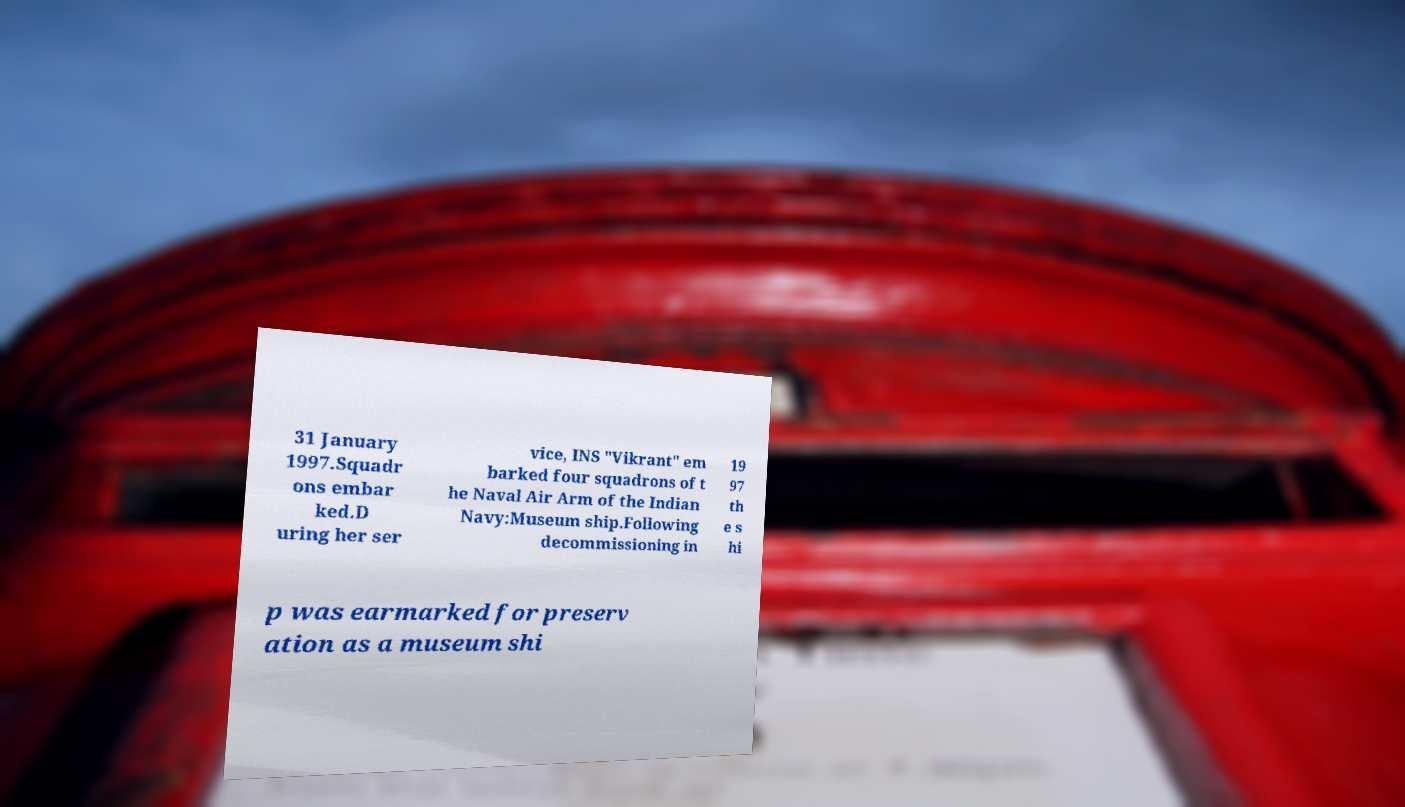I need the written content from this picture converted into text. Can you do that? 31 January 1997.Squadr ons embar ked.D uring her ser vice, INS "Vikrant" em barked four squadrons of t he Naval Air Arm of the Indian Navy:Museum ship.Following decommissioning in 19 97 th e s hi p was earmarked for preserv ation as a museum shi 